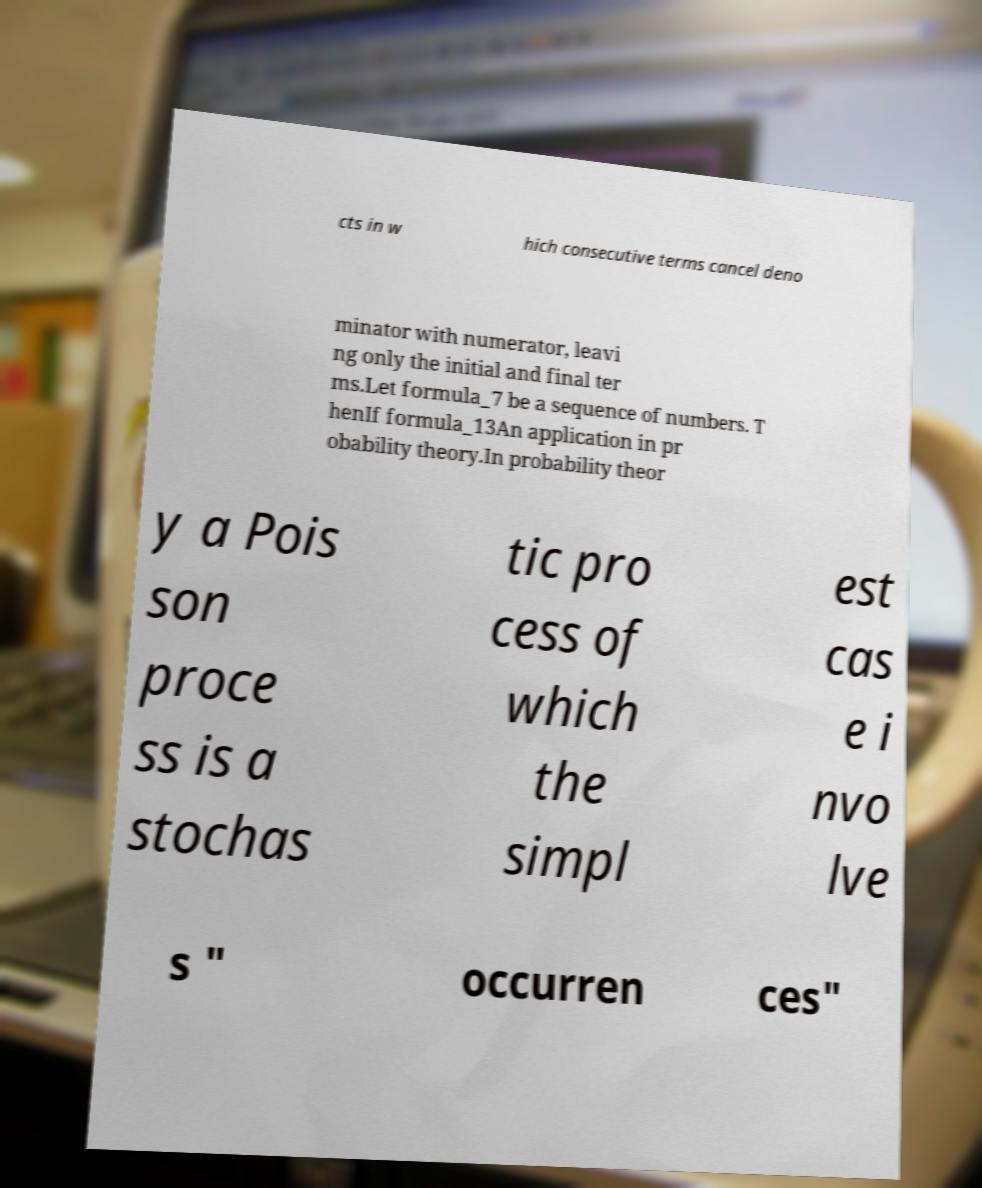Please read and relay the text visible in this image. What does it say? cts in w hich consecutive terms cancel deno minator with numerator, leavi ng only the initial and final ter ms.Let formula_7 be a sequence of numbers. T henIf formula_13An application in pr obability theory.In probability theor y a Pois son proce ss is a stochas tic pro cess of which the simpl est cas e i nvo lve s " occurren ces" 